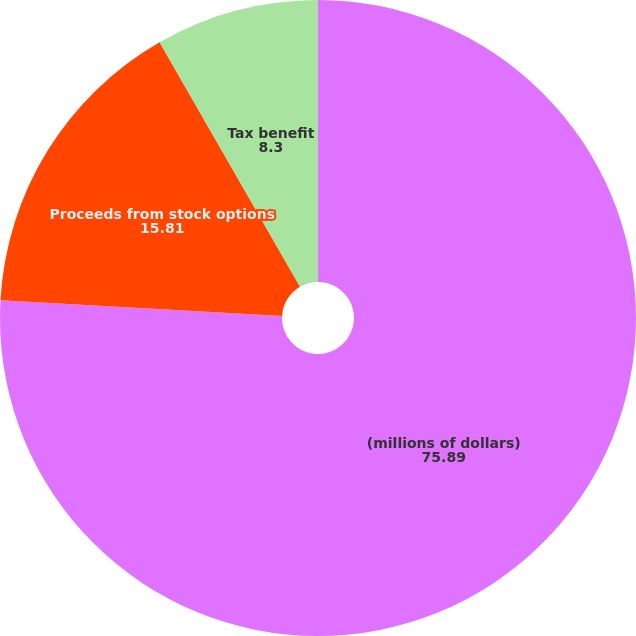Convert chart to OTSL. <chart><loc_0><loc_0><loc_500><loc_500><pie_chart><fcel>(millions of dollars)<fcel>Proceeds from stock options<fcel>Tax benefit<nl><fcel>75.89%<fcel>15.81%<fcel>8.3%<nl></chart> 